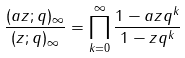<formula> <loc_0><loc_0><loc_500><loc_500>\frac { ( a z ; q ) _ { \infty } } { ( z ; q ) _ { \infty } } = \prod _ { k = 0 } ^ { \infty } \frac { 1 - a z q ^ { k } } { 1 - z q ^ { k } }</formula> 